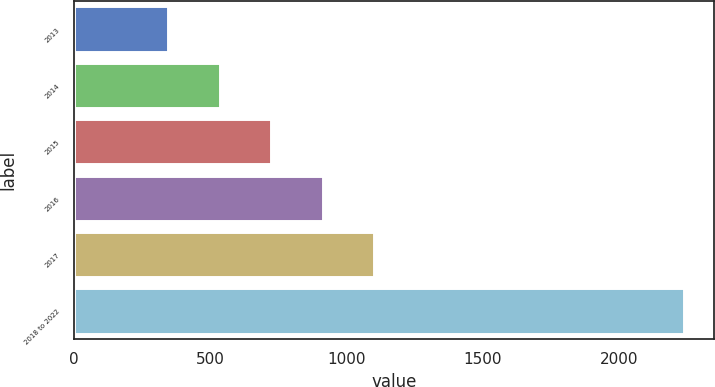Convert chart. <chart><loc_0><loc_0><loc_500><loc_500><bar_chart><fcel>2013<fcel>2014<fcel>2015<fcel>2016<fcel>2017<fcel>2018 to 2022<nl><fcel>347<fcel>536.1<fcel>725.2<fcel>914.3<fcel>1103.4<fcel>2238<nl></chart> 